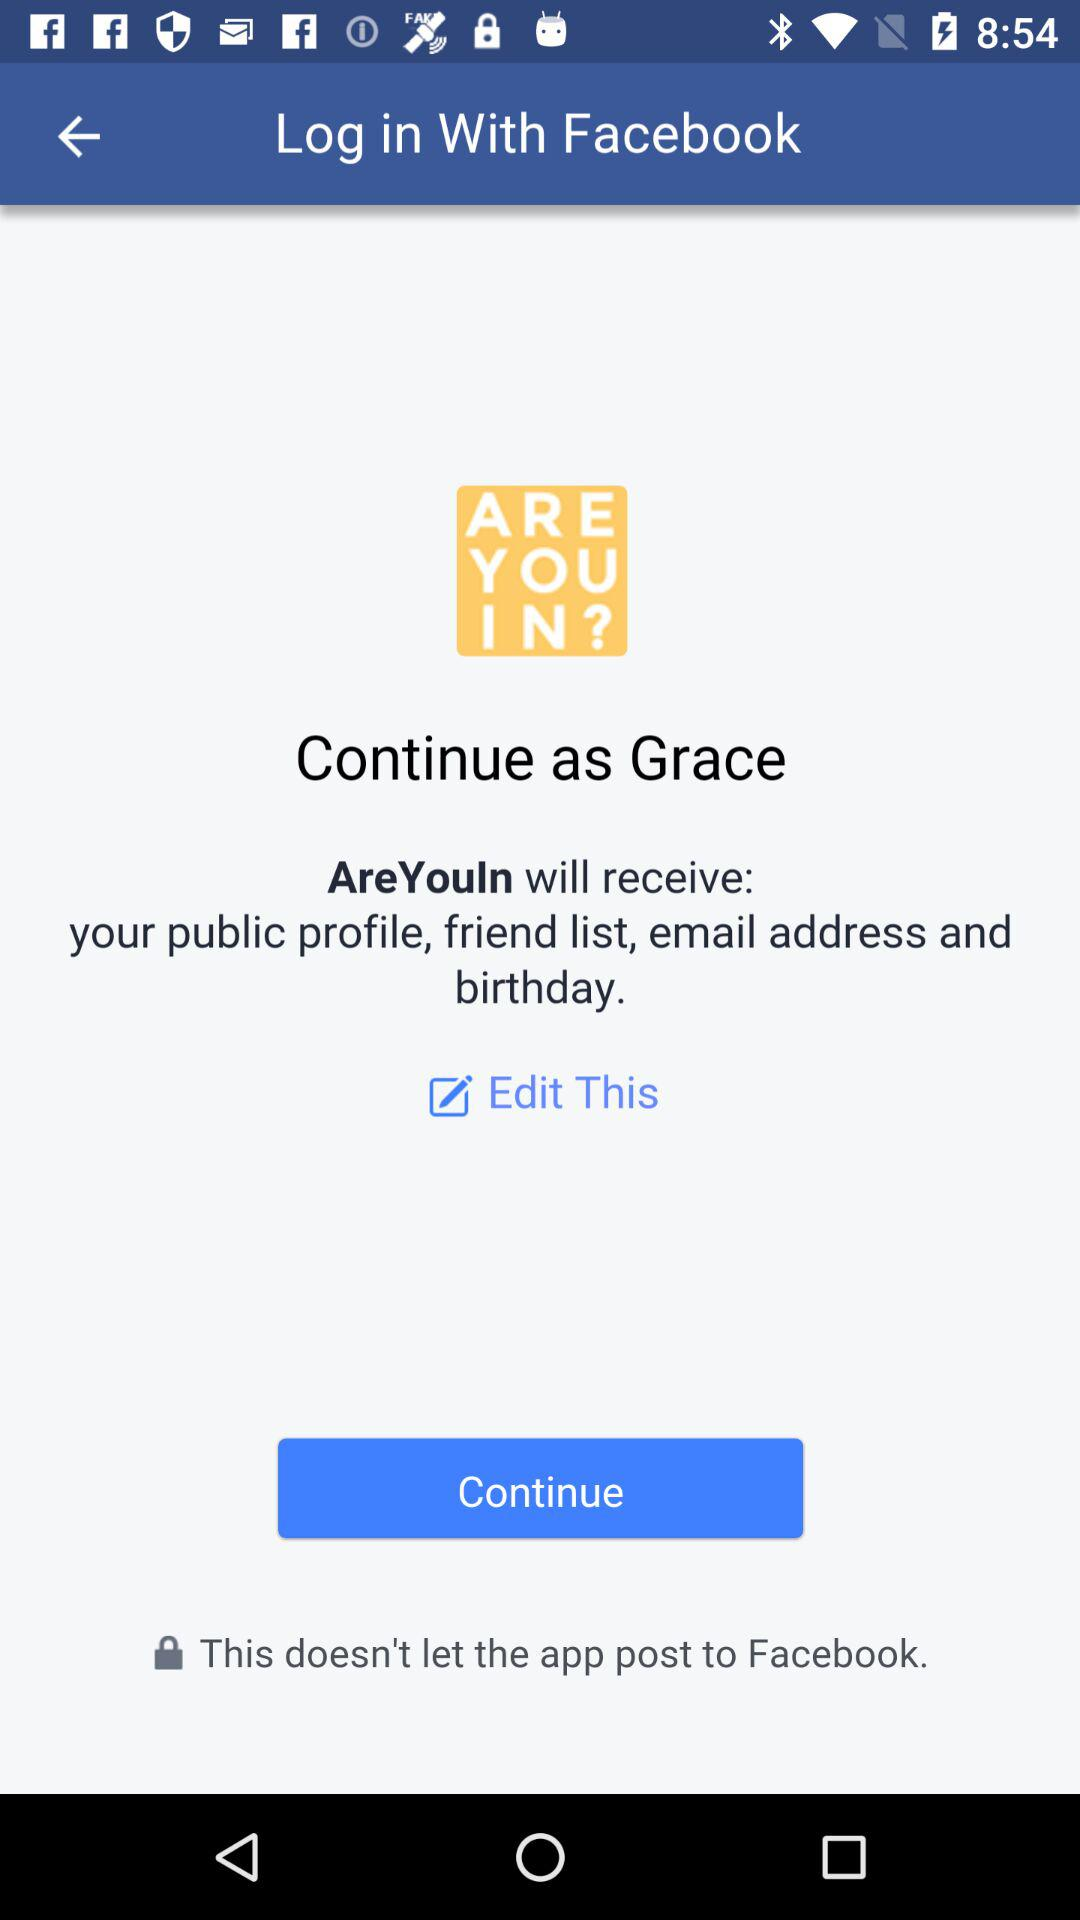How can we log in? You can log in with "Facebook". 